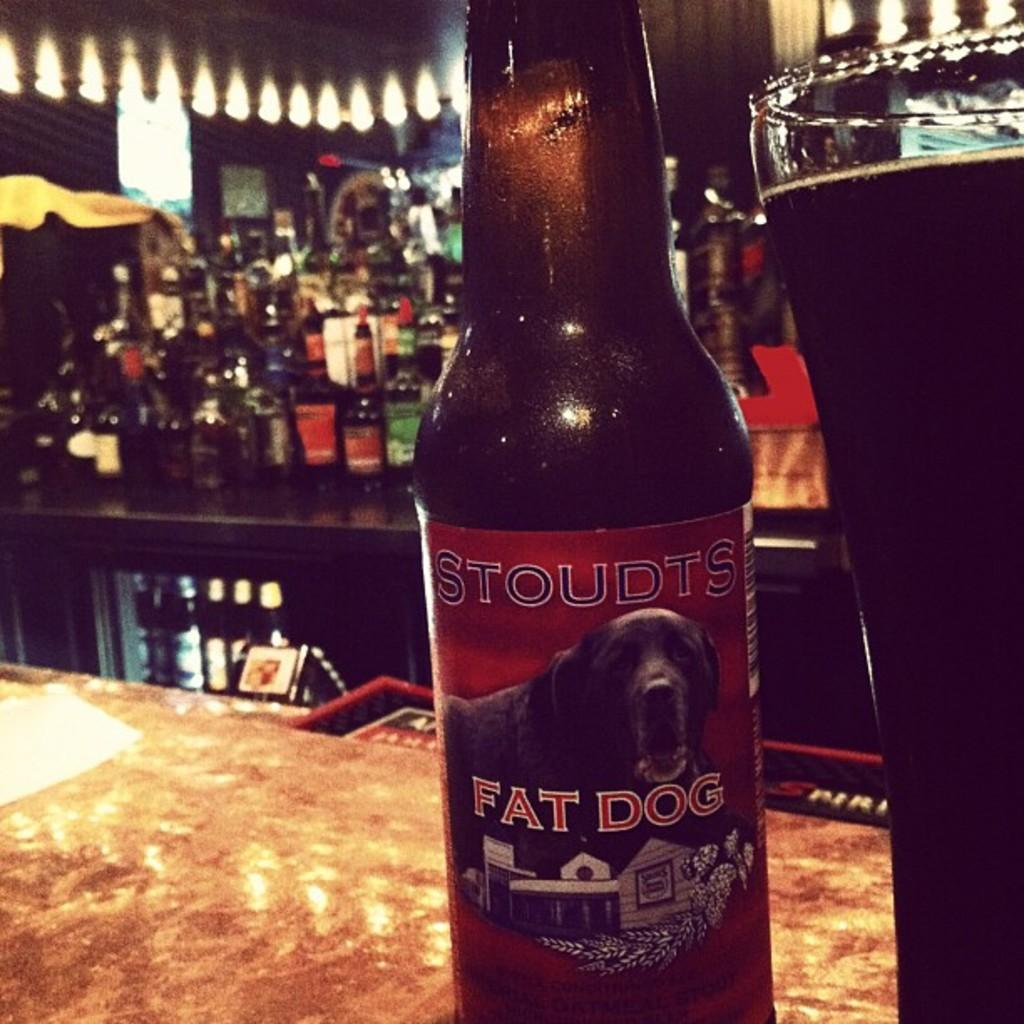<image>
Summarize the visual content of the image. A glass bottle of Stroudts Fat Dog beer. 